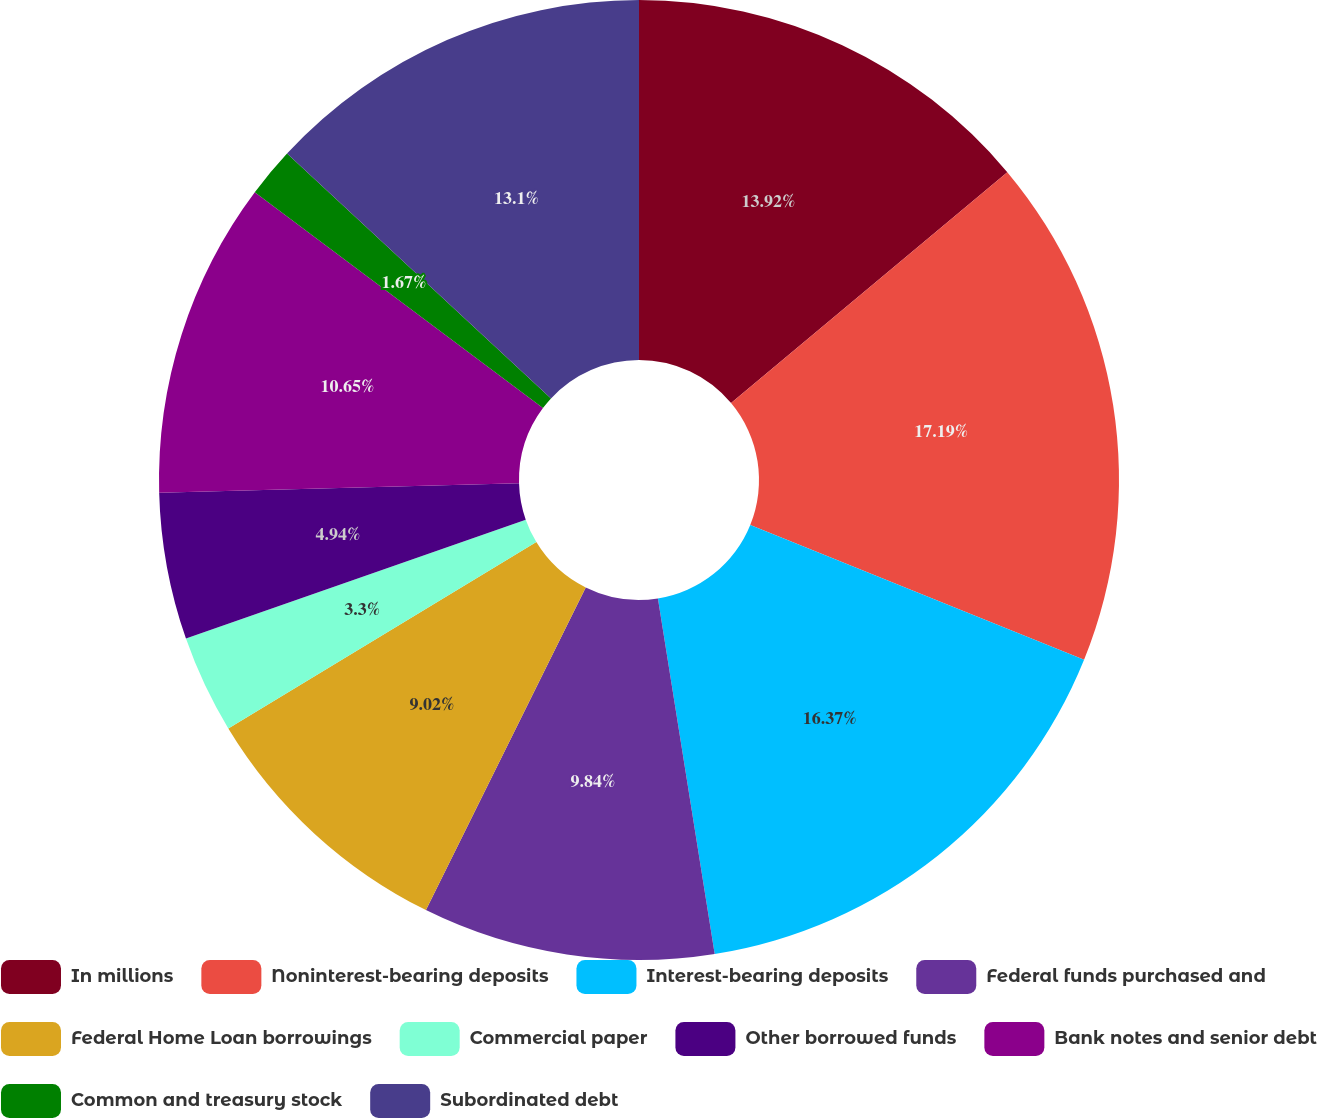Convert chart to OTSL. <chart><loc_0><loc_0><loc_500><loc_500><pie_chart><fcel>In millions<fcel>Noninterest-bearing deposits<fcel>Interest-bearing deposits<fcel>Federal funds purchased and<fcel>Federal Home Loan borrowings<fcel>Commercial paper<fcel>Other borrowed funds<fcel>Bank notes and senior debt<fcel>Common and treasury stock<fcel>Subordinated debt<nl><fcel>13.92%<fcel>17.19%<fcel>16.37%<fcel>9.84%<fcel>9.02%<fcel>3.3%<fcel>4.94%<fcel>10.65%<fcel>1.67%<fcel>13.1%<nl></chart> 